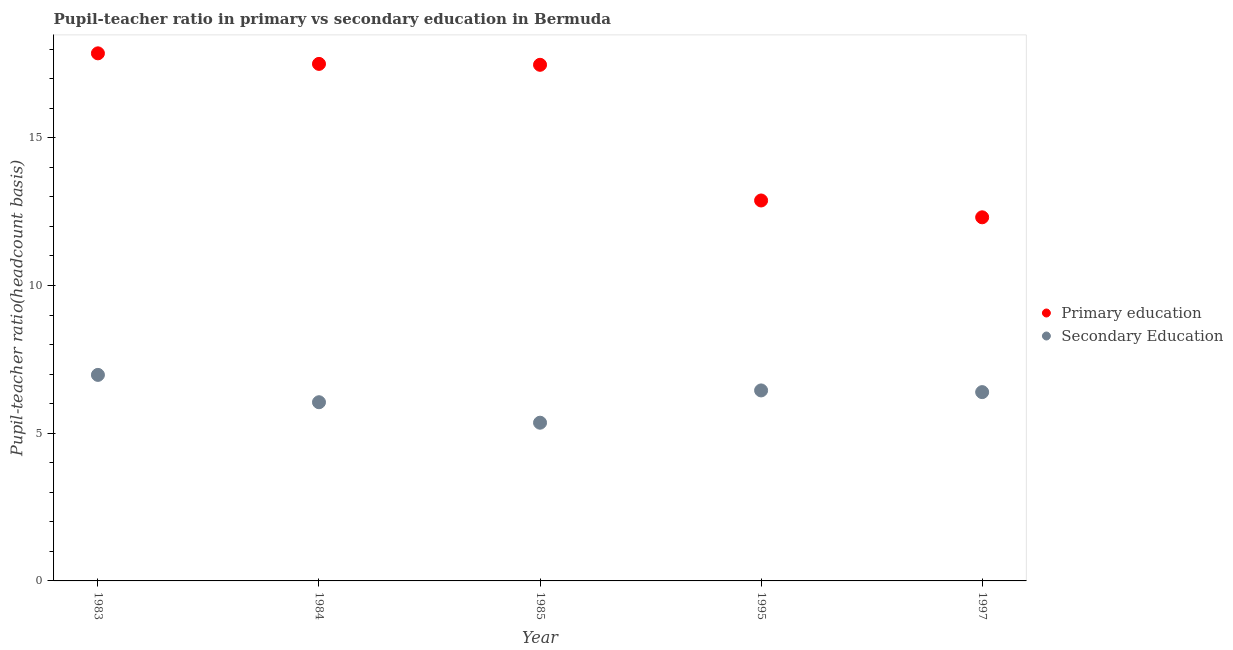How many different coloured dotlines are there?
Your response must be concise. 2. What is the pupil teacher ratio on secondary education in 1985?
Your answer should be compact. 5.36. Across all years, what is the maximum pupil teacher ratio on secondary education?
Your response must be concise. 6.97. Across all years, what is the minimum pupil-teacher ratio in primary education?
Offer a very short reply. 12.31. What is the total pupil-teacher ratio in primary education in the graph?
Ensure brevity in your answer.  78.01. What is the difference between the pupil-teacher ratio in primary education in 1995 and that in 1997?
Offer a very short reply. 0.57. What is the difference between the pupil teacher ratio on secondary education in 1984 and the pupil-teacher ratio in primary education in 1995?
Your answer should be compact. -6.83. What is the average pupil teacher ratio on secondary education per year?
Offer a very short reply. 6.24. In the year 1985, what is the difference between the pupil teacher ratio on secondary education and pupil-teacher ratio in primary education?
Offer a very short reply. -12.11. In how many years, is the pupil teacher ratio on secondary education greater than 7?
Ensure brevity in your answer.  0. What is the ratio of the pupil-teacher ratio in primary education in 1985 to that in 1995?
Your response must be concise. 1.36. Is the difference between the pupil teacher ratio on secondary education in 1985 and 1995 greater than the difference between the pupil-teacher ratio in primary education in 1985 and 1995?
Keep it short and to the point. No. What is the difference between the highest and the second highest pupil-teacher ratio in primary education?
Make the answer very short. 0.36. What is the difference between the highest and the lowest pupil teacher ratio on secondary education?
Provide a succinct answer. 1.62. Is the pupil-teacher ratio in primary education strictly greater than the pupil teacher ratio on secondary education over the years?
Keep it short and to the point. Yes. How many dotlines are there?
Ensure brevity in your answer.  2. How many years are there in the graph?
Give a very brief answer. 5. What is the difference between two consecutive major ticks on the Y-axis?
Ensure brevity in your answer.  5. Where does the legend appear in the graph?
Provide a short and direct response. Center right. How are the legend labels stacked?
Offer a very short reply. Vertical. What is the title of the graph?
Your answer should be very brief. Pupil-teacher ratio in primary vs secondary education in Bermuda. Does "Registered firms" appear as one of the legend labels in the graph?
Your answer should be very brief. No. What is the label or title of the X-axis?
Keep it short and to the point. Year. What is the label or title of the Y-axis?
Your response must be concise. Pupil-teacher ratio(headcount basis). What is the Pupil-teacher ratio(headcount basis) in Primary education in 1983?
Your answer should be compact. 17.86. What is the Pupil-teacher ratio(headcount basis) of Secondary Education in 1983?
Your answer should be very brief. 6.97. What is the Pupil-teacher ratio(headcount basis) of Primary education in 1984?
Make the answer very short. 17.5. What is the Pupil-teacher ratio(headcount basis) of Secondary Education in 1984?
Make the answer very short. 6.05. What is the Pupil-teacher ratio(headcount basis) of Primary education in 1985?
Provide a short and direct response. 17.47. What is the Pupil-teacher ratio(headcount basis) of Secondary Education in 1985?
Your answer should be compact. 5.36. What is the Pupil-teacher ratio(headcount basis) of Primary education in 1995?
Give a very brief answer. 12.88. What is the Pupil-teacher ratio(headcount basis) of Secondary Education in 1995?
Make the answer very short. 6.45. What is the Pupil-teacher ratio(headcount basis) in Primary education in 1997?
Your response must be concise. 12.31. What is the Pupil-teacher ratio(headcount basis) in Secondary Education in 1997?
Make the answer very short. 6.39. Across all years, what is the maximum Pupil-teacher ratio(headcount basis) of Primary education?
Your answer should be compact. 17.86. Across all years, what is the maximum Pupil-teacher ratio(headcount basis) in Secondary Education?
Give a very brief answer. 6.97. Across all years, what is the minimum Pupil-teacher ratio(headcount basis) in Primary education?
Make the answer very short. 12.31. Across all years, what is the minimum Pupil-teacher ratio(headcount basis) in Secondary Education?
Provide a short and direct response. 5.36. What is the total Pupil-teacher ratio(headcount basis) in Primary education in the graph?
Keep it short and to the point. 78.01. What is the total Pupil-teacher ratio(headcount basis) of Secondary Education in the graph?
Make the answer very short. 31.21. What is the difference between the Pupil-teacher ratio(headcount basis) in Primary education in 1983 and that in 1984?
Make the answer very short. 0.36. What is the difference between the Pupil-teacher ratio(headcount basis) of Secondary Education in 1983 and that in 1984?
Make the answer very short. 0.93. What is the difference between the Pupil-teacher ratio(headcount basis) of Primary education in 1983 and that in 1985?
Make the answer very short. 0.39. What is the difference between the Pupil-teacher ratio(headcount basis) of Secondary Education in 1983 and that in 1985?
Offer a terse response. 1.62. What is the difference between the Pupil-teacher ratio(headcount basis) in Primary education in 1983 and that in 1995?
Ensure brevity in your answer.  4.98. What is the difference between the Pupil-teacher ratio(headcount basis) in Secondary Education in 1983 and that in 1995?
Give a very brief answer. 0.53. What is the difference between the Pupil-teacher ratio(headcount basis) of Primary education in 1983 and that in 1997?
Your response must be concise. 5.55. What is the difference between the Pupil-teacher ratio(headcount basis) of Secondary Education in 1983 and that in 1997?
Give a very brief answer. 0.58. What is the difference between the Pupil-teacher ratio(headcount basis) in Primary education in 1984 and that in 1985?
Provide a succinct answer. 0.03. What is the difference between the Pupil-teacher ratio(headcount basis) in Secondary Education in 1984 and that in 1985?
Give a very brief answer. 0.69. What is the difference between the Pupil-teacher ratio(headcount basis) of Primary education in 1984 and that in 1995?
Offer a very short reply. 4.62. What is the difference between the Pupil-teacher ratio(headcount basis) of Secondary Education in 1984 and that in 1995?
Your answer should be compact. -0.4. What is the difference between the Pupil-teacher ratio(headcount basis) of Primary education in 1984 and that in 1997?
Your answer should be compact. 5.19. What is the difference between the Pupil-teacher ratio(headcount basis) of Secondary Education in 1984 and that in 1997?
Your answer should be very brief. -0.34. What is the difference between the Pupil-teacher ratio(headcount basis) in Primary education in 1985 and that in 1995?
Give a very brief answer. 4.59. What is the difference between the Pupil-teacher ratio(headcount basis) of Secondary Education in 1985 and that in 1995?
Keep it short and to the point. -1.09. What is the difference between the Pupil-teacher ratio(headcount basis) in Primary education in 1985 and that in 1997?
Your answer should be very brief. 5.16. What is the difference between the Pupil-teacher ratio(headcount basis) of Secondary Education in 1985 and that in 1997?
Provide a succinct answer. -1.04. What is the difference between the Pupil-teacher ratio(headcount basis) of Primary education in 1995 and that in 1997?
Your response must be concise. 0.57. What is the difference between the Pupil-teacher ratio(headcount basis) in Secondary Education in 1995 and that in 1997?
Offer a very short reply. 0.06. What is the difference between the Pupil-teacher ratio(headcount basis) in Primary education in 1983 and the Pupil-teacher ratio(headcount basis) in Secondary Education in 1984?
Your answer should be compact. 11.81. What is the difference between the Pupil-teacher ratio(headcount basis) of Primary education in 1983 and the Pupil-teacher ratio(headcount basis) of Secondary Education in 1985?
Give a very brief answer. 12.5. What is the difference between the Pupil-teacher ratio(headcount basis) in Primary education in 1983 and the Pupil-teacher ratio(headcount basis) in Secondary Education in 1995?
Ensure brevity in your answer.  11.41. What is the difference between the Pupil-teacher ratio(headcount basis) in Primary education in 1983 and the Pupil-teacher ratio(headcount basis) in Secondary Education in 1997?
Your answer should be very brief. 11.47. What is the difference between the Pupil-teacher ratio(headcount basis) of Primary education in 1984 and the Pupil-teacher ratio(headcount basis) of Secondary Education in 1985?
Provide a succinct answer. 12.14. What is the difference between the Pupil-teacher ratio(headcount basis) of Primary education in 1984 and the Pupil-teacher ratio(headcount basis) of Secondary Education in 1995?
Your answer should be compact. 11.05. What is the difference between the Pupil-teacher ratio(headcount basis) in Primary education in 1984 and the Pupil-teacher ratio(headcount basis) in Secondary Education in 1997?
Keep it short and to the point. 11.11. What is the difference between the Pupil-teacher ratio(headcount basis) in Primary education in 1985 and the Pupil-teacher ratio(headcount basis) in Secondary Education in 1995?
Offer a terse response. 11.02. What is the difference between the Pupil-teacher ratio(headcount basis) of Primary education in 1985 and the Pupil-teacher ratio(headcount basis) of Secondary Education in 1997?
Offer a very short reply. 11.08. What is the difference between the Pupil-teacher ratio(headcount basis) in Primary education in 1995 and the Pupil-teacher ratio(headcount basis) in Secondary Education in 1997?
Your answer should be compact. 6.49. What is the average Pupil-teacher ratio(headcount basis) in Primary education per year?
Your answer should be compact. 15.6. What is the average Pupil-teacher ratio(headcount basis) in Secondary Education per year?
Your answer should be compact. 6.24. In the year 1983, what is the difference between the Pupil-teacher ratio(headcount basis) of Primary education and Pupil-teacher ratio(headcount basis) of Secondary Education?
Offer a very short reply. 10.88. In the year 1984, what is the difference between the Pupil-teacher ratio(headcount basis) of Primary education and Pupil-teacher ratio(headcount basis) of Secondary Education?
Offer a terse response. 11.45. In the year 1985, what is the difference between the Pupil-teacher ratio(headcount basis) of Primary education and Pupil-teacher ratio(headcount basis) of Secondary Education?
Provide a short and direct response. 12.11. In the year 1995, what is the difference between the Pupil-teacher ratio(headcount basis) of Primary education and Pupil-teacher ratio(headcount basis) of Secondary Education?
Your answer should be very brief. 6.43. In the year 1997, what is the difference between the Pupil-teacher ratio(headcount basis) of Primary education and Pupil-teacher ratio(headcount basis) of Secondary Education?
Make the answer very short. 5.92. What is the ratio of the Pupil-teacher ratio(headcount basis) of Primary education in 1983 to that in 1984?
Keep it short and to the point. 1.02. What is the ratio of the Pupil-teacher ratio(headcount basis) of Secondary Education in 1983 to that in 1984?
Your answer should be very brief. 1.15. What is the ratio of the Pupil-teacher ratio(headcount basis) of Primary education in 1983 to that in 1985?
Your answer should be very brief. 1.02. What is the ratio of the Pupil-teacher ratio(headcount basis) of Secondary Education in 1983 to that in 1985?
Offer a terse response. 1.3. What is the ratio of the Pupil-teacher ratio(headcount basis) in Primary education in 1983 to that in 1995?
Your response must be concise. 1.39. What is the ratio of the Pupil-teacher ratio(headcount basis) in Secondary Education in 1983 to that in 1995?
Offer a terse response. 1.08. What is the ratio of the Pupil-teacher ratio(headcount basis) of Primary education in 1983 to that in 1997?
Your response must be concise. 1.45. What is the ratio of the Pupil-teacher ratio(headcount basis) in Secondary Education in 1983 to that in 1997?
Ensure brevity in your answer.  1.09. What is the ratio of the Pupil-teacher ratio(headcount basis) of Primary education in 1984 to that in 1985?
Your response must be concise. 1. What is the ratio of the Pupil-teacher ratio(headcount basis) in Secondary Education in 1984 to that in 1985?
Your answer should be very brief. 1.13. What is the ratio of the Pupil-teacher ratio(headcount basis) in Primary education in 1984 to that in 1995?
Provide a short and direct response. 1.36. What is the ratio of the Pupil-teacher ratio(headcount basis) of Secondary Education in 1984 to that in 1995?
Your answer should be compact. 0.94. What is the ratio of the Pupil-teacher ratio(headcount basis) in Primary education in 1984 to that in 1997?
Your answer should be very brief. 1.42. What is the ratio of the Pupil-teacher ratio(headcount basis) in Secondary Education in 1984 to that in 1997?
Your answer should be compact. 0.95. What is the ratio of the Pupil-teacher ratio(headcount basis) in Primary education in 1985 to that in 1995?
Offer a terse response. 1.36. What is the ratio of the Pupil-teacher ratio(headcount basis) of Secondary Education in 1985 to that in 1995?
Provide a succinct answer. 0.83. What is the ratio of the Pupil-teacher ratio(headcount basis) in Primary education in 1985 to that in 1997?
Offer a very short reply. 1.42. What is the ratio of the Pupil-teacher ratio(headcount basis) in Secondary Education in 1985 to that in 1997?
Keep it short and to the point. 0.84. What is the ratio of the Pupil-teacher ratio(headcount basis) of Primary education in 1995 to that in 1997?
Provide a short and direct response. 1.05. What is the difference between the highest and the second highest Pupil-teacher ratio(headcount basis) of Primary education?
Provide a short and direct response. 0.36. What is the difference between the highest and the second highest Pupil-teacher ratio(headcount basis) of Secondary Education?
Make the answer very short. 0.53. What is the difference between the highest and the lowest Pupil-teacher ratio(headcount basis) of Primary education?
Give a very brief answer. 5.55. What is the difference between the highest and the lowest Pupil-teacher ratio(headcount basis) in Secondary Education?
Make the answer very short. 1.62. 